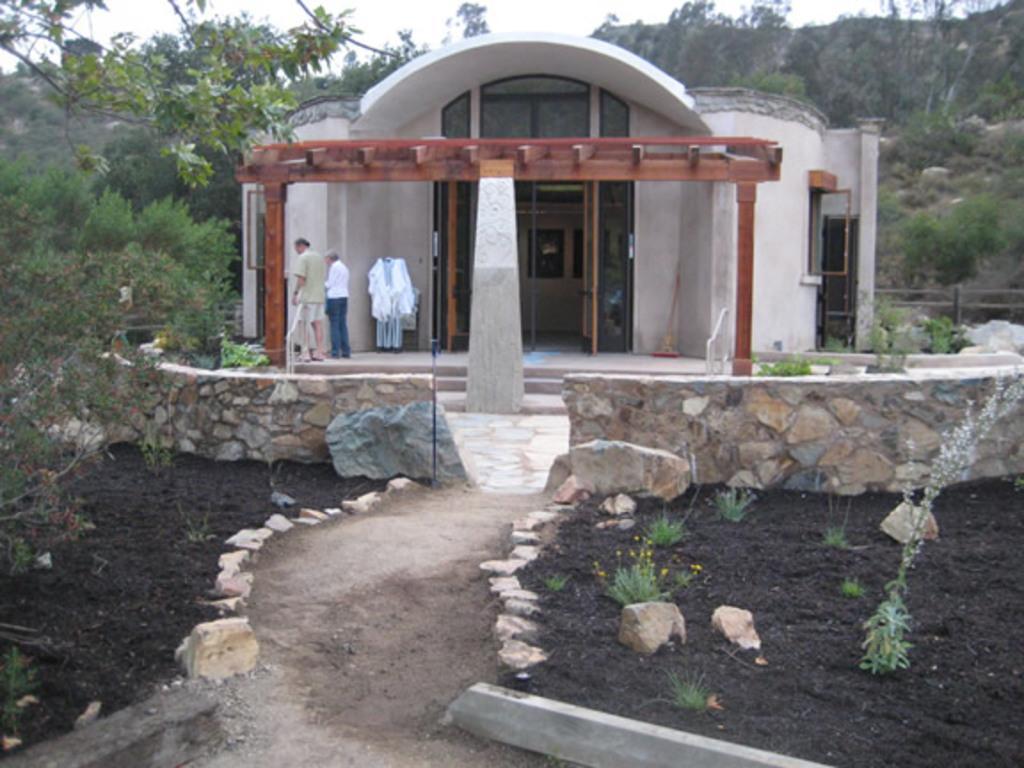How would you summarize this image in a sentence or two? In this image there is a pillar in the center and behind the pillar there is a house and there are persons standing. On the left side there are trees and in the background there are trees, there are stones, and there is a fence. 